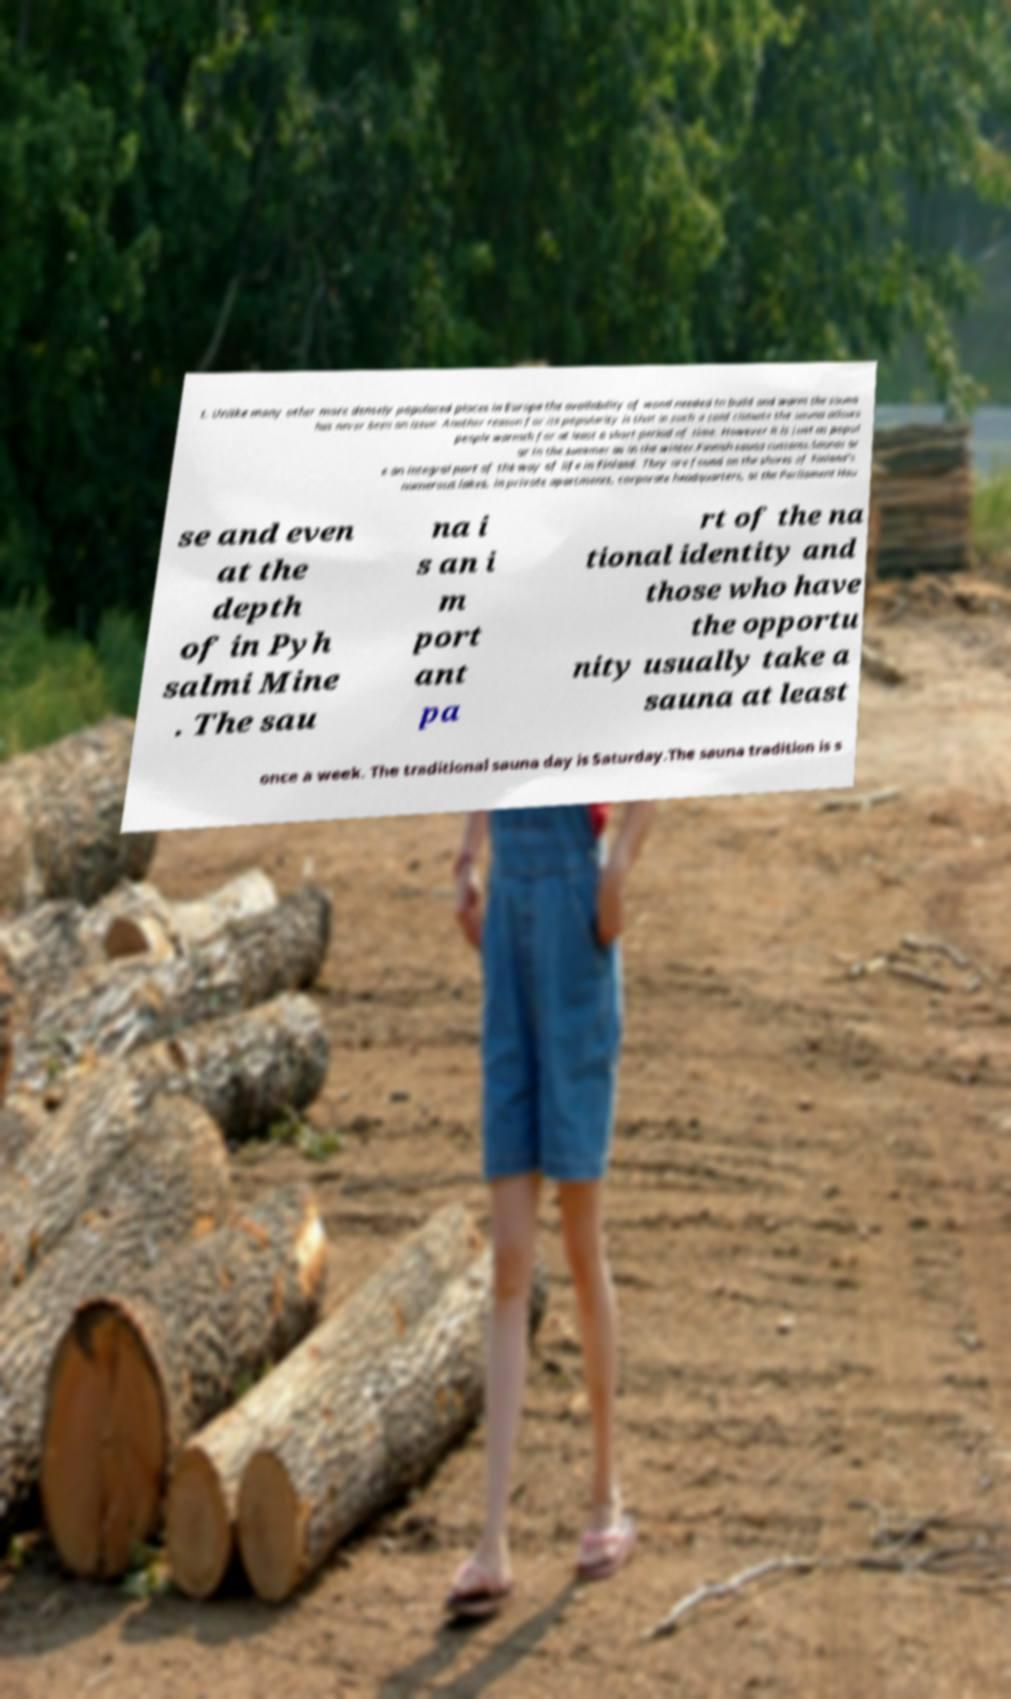Could you assist in decoding the text presented in this image and type it out clearly? t. Unlike many other more densely populated places in Europe the availability of wood needed to build and warm the sauna has never been an issue. Another reason for its popularity is that in such a cold climate the sauna allows people warmth for at least a short period of time. However it is just as popul ar in the summer as in the winter.Finnish sauna customs.Saunas ar e an integral part of the way of life in Finland. They are found on the shores of Finland's numerous lakes, in private apartments, corporate headquarters, at the Parliament Hou se and even at the depth of in Pyh salmi Mine . The sau na i s an i m port ant pa rt of the na tional identity and those who have the opportu nity usually take a sauna at least once a week. The traditional sauna day is Saturday.The sauna tradition is s 